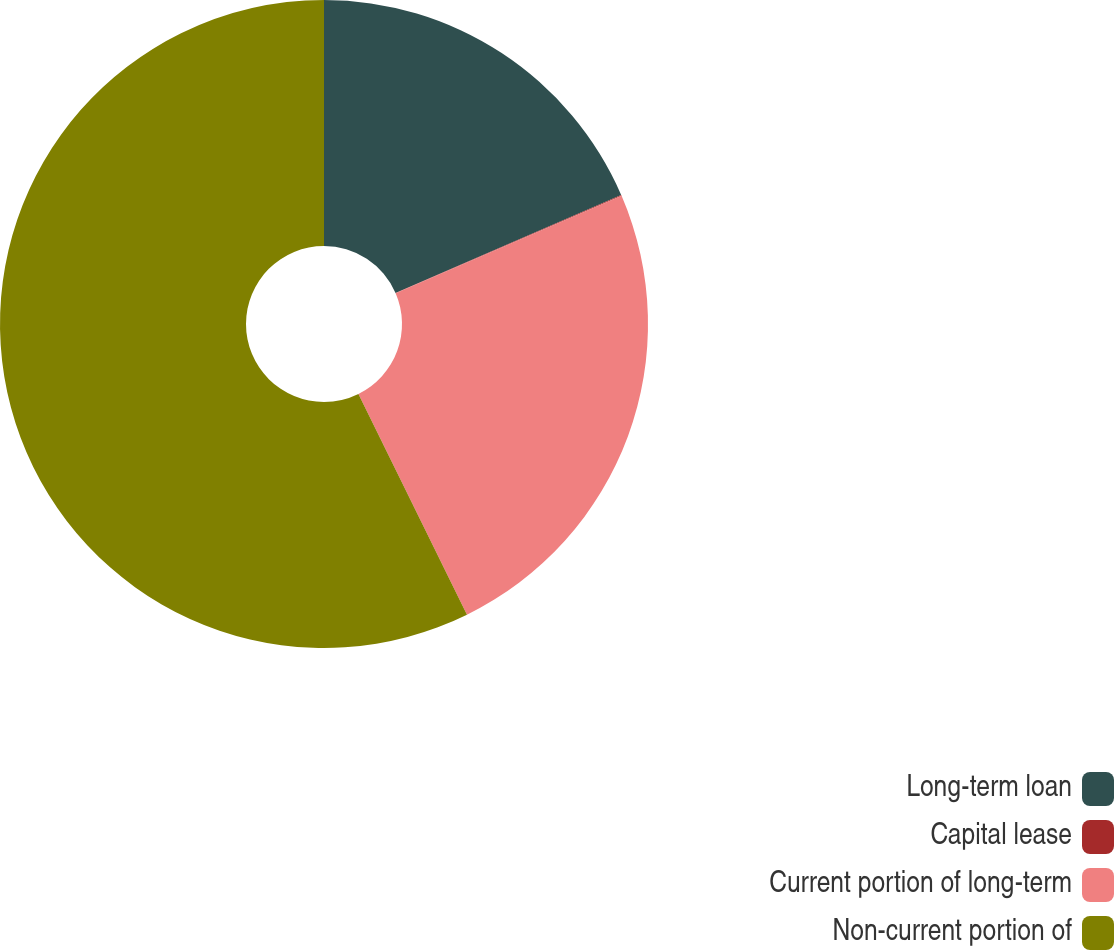<chart> <loc_0><loc_0><loc_500><loc_500><pie_chart><fcel>Long-term loan<fcel>Capital lease<fcel>Current portion of long-term<fcel>Non-current portion of<nl><fcel>18.48%<fcel>0.05%<fcel>24.2%<fcel>57.28%<nl></chart> 